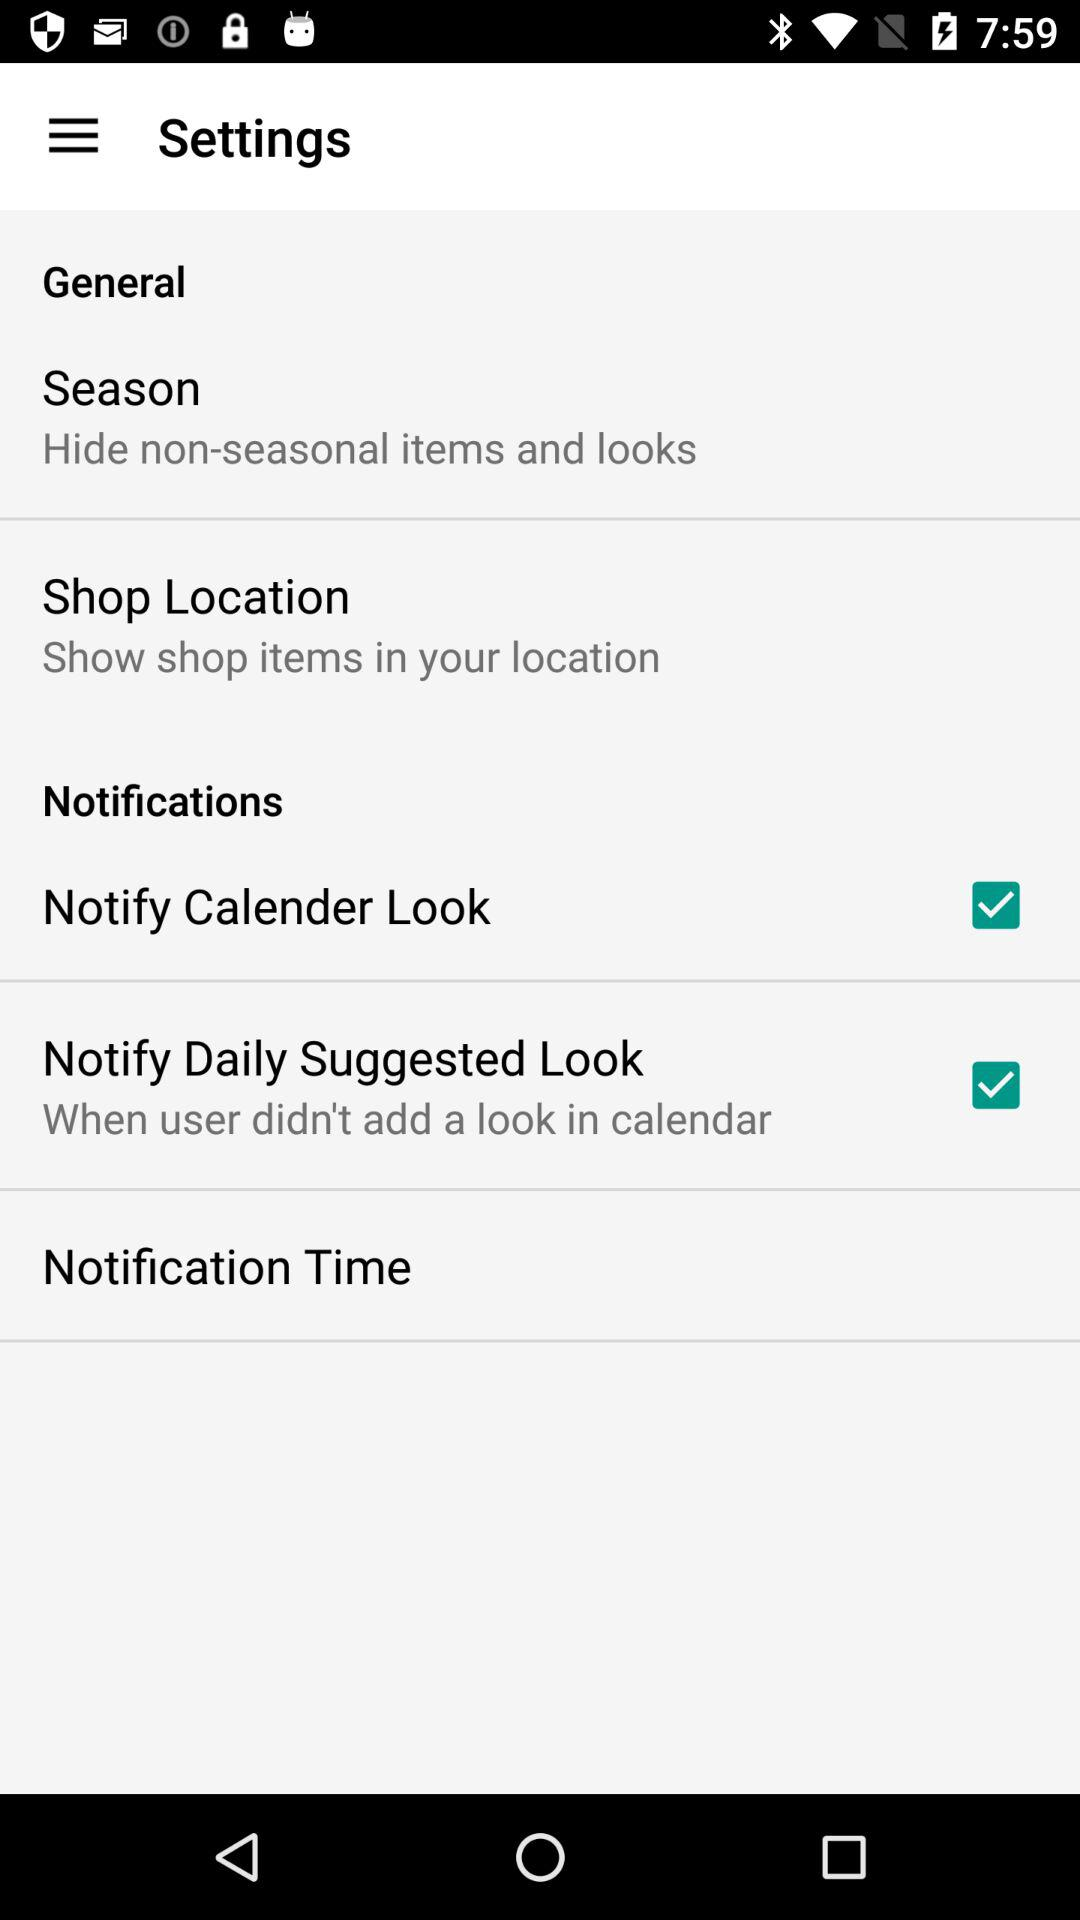How many items are in the Notifications section?
Answer the question using a single word or phrase. 3 